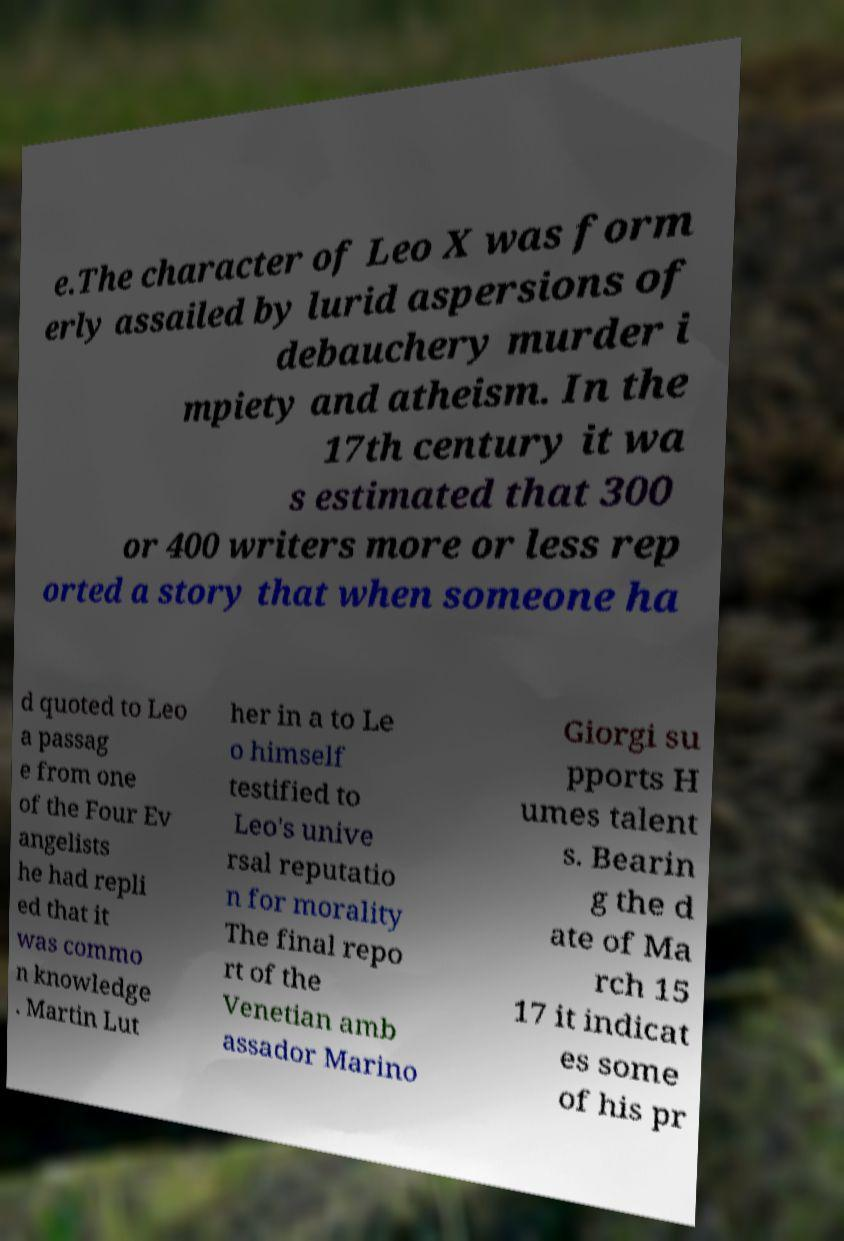I need the written content from this picture converted into text. Can you do that? e.The character of Leo X was form erly assailed by lurid aspersions of debauchery murder i mpiety and atheism. In the 17th century it wa s estimated that 300 or 400 writers more or less rep orted a story that when someone ha d quoted to Leo a passag e from one of the Four Ev angelists he had repli ed that it was commo n knowledge . Martin Lut her in a to Le o himself testified to Leo's unive rsal reputatio n for morality The final repo rt of the Venetian amb assador Marino Giorgi su pports H umes talent s. Bearin g the d ate of Ma rch 15 17 it indicat es some of his pr 